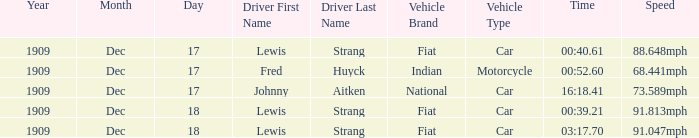What car/motorcycle goes 91.813mph? Fiat. 